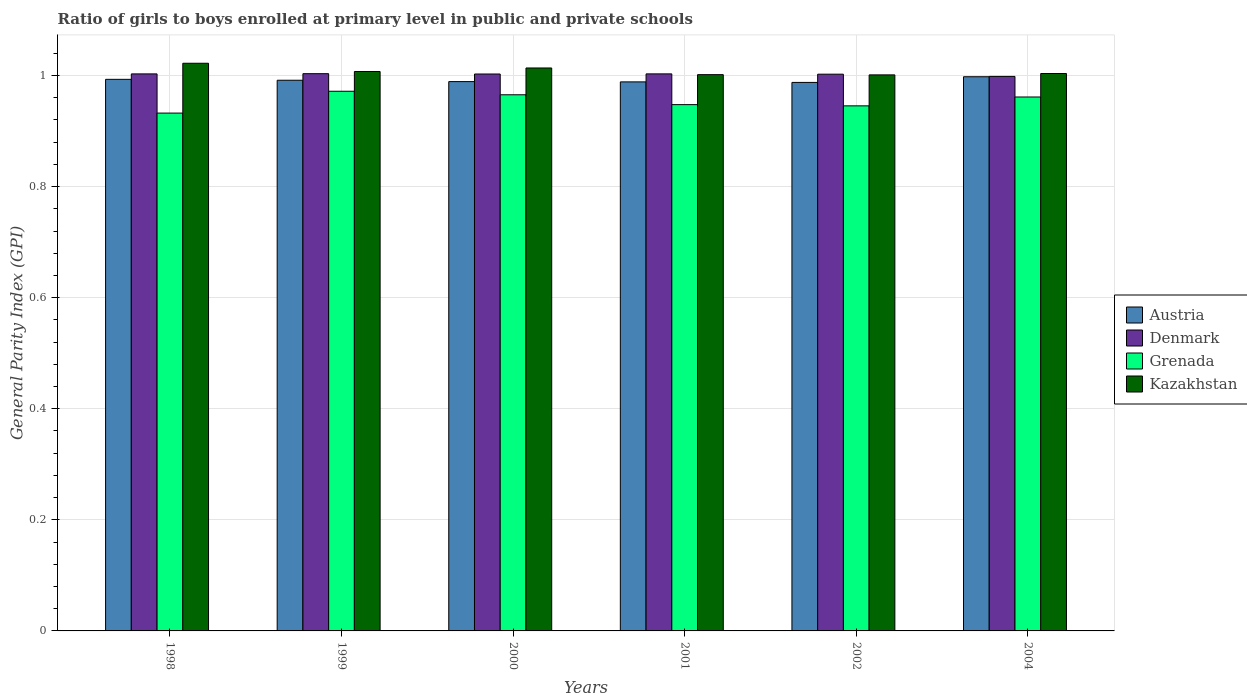How many groups of bars are there?
Ensure brevity in your answer.  6. How many bars are there on the 6th tick from the left?
Offer a very short reply. 4. What is the general parity index in Kazakhstan in 2001?
Keep it short and to the point. 1. Across all years, what is the maximum general parity index in Denmark?
Ensure brevity in your answer.  1. Across all years, what is the minimum general parity index in Grenada?
Give a very brief answer. 0.93. What is the total general parity index in Grenada in the graph?
Provide a succinct answer. 5.72. What is the difference between the general parity index in Grenada in 1998 and that in 2001?
Make the answer very short. -0.02. What is the difference between the general parity index in Grenada in 2000 and the general parity index in Kazakhstan in 1999?
Your answer should be very brief. -0.04. What is the average general parity index in Denmark per year?
Your response must be concise. 1. In the year 2000, what is the difference between the general parity index in Austria and general parity index in Grenada?
Keep it short and to the point. 0.02. What is the ratio of the general parity index in Denmark in 1999 to that in 2000?
Your answer should be very brief. 1. Is the general parity index in Denmark in 1998 less than that in 1999?
Offer a terse response. Yes. Is the difference between the general parity index in Austria in 1999 and 2002 greater than the difference between the general parity index in Grenada in 1999 and 2002?
Ensure brevity in your answer.  No. What is the difference between the highest and the second highest general parity index in Austria?
Ensure brevity in your answer.  0. What is the difference between the highest and the lowest general parity index in Kazakhstan?
Ensure brevity in your answer.  0.02. Is the sum of the general parity index in Grenada in 1999 and 2001 greater than the maximum general parity index in Kazakhstan across all years?
Your answer should be very brief. Yes. What does the 4th bar from the left in 1998 represents?
Make the answer very short. Kazakhstan. What does the 2nd bar from the right in 1998 represents?
Your answer should be compact. Grenada. Is it the case that in every year, the sum of the general parity index in Austria and general parity index in Grenada is greater than the general parity index in Kazakhstan?
Provide a short and direct response. Yes. Are the values on the major ticks of Y-axis written in scientific E-notation?
Keep it short and to the point. No. Does the graph contain grids?
Give a very brief answer. Yes. How many legend labels are there?
Keep it short and to the point. 4. How are the legend labels stacked?
Keep it short and to the point. Vertical. What is the title of the graph?
Provide a short and direct response. Ratio of girls to boys enrolled at primary level in public and private schools. Does "Sweden" appear as one of the legend labels in the graph?
Your answer should be very brief. No. What is the label or title of the X-axis?
Keep it short and to the point. Years. What is the label or title of the Y-axis?
Your answer should be compact. General Parity Index (GPI). What is the General Parity Index (GPI) of Austria in 1998?
Provide a succinct answer. 0.99. What is the General Parity Index (GPI) in Grenada in 1998?
Provide a short and direct response. 0.93. What is the General Parity Index (GPI) in Kazakhstan in 1998?
Your answer should be compact. 1.02. What is the General Parity Index (GPI) of Austria in 1999?
Offer a terse response. 0.99. What is the General Parity Index (GPI) in Denmark in 1999?
Make the answer very short. 1. What is the General Parity Index (GPI) in Grenada in 1999?
Give a very brief answer. 0.97. What is the General Parity Index (GPI) of Kazakhstan in 1999?
Provide a short and direct response. 1.01. What is the General Parity Index (GPI) in Austria in 2000?
Offer a terse response. 0.99. What is the General Parity Index (GPI) in Denmark in 2000?
Provide a succinct answer. 1. What is the General Parity Index (GPI) of Grenada in 2000?
Offer a very short reply. 0.97. What is the General Parity Index (GPI) of Kazakhstan in 2000?
Your answer should be very brief. 1.01. What is the General Parity Index (GPI) in Austria in 2001?
Ensure brevity in your answer.  0.99. What is the General Parity Index (GPI) of Denmark in 2001?
Make the answer very short. 1. What is the General Parity Index (GPI) of Grenada in 2001?
Ensure brevity in your answer.  0.95. What is the General Parity Index (GPI) in Kazakhstan in 2001?
Give a very brief answer. 1. What is the General Parity Index (GPI) in Austria in 2002?
Offer a very short reply. 0.99. What is the General Parity Index (GPI) in Denmark in 2002?
Your response must be concise. 1. What is the General Parity Index (GPI) of Grenada in 2002?
Keep it short and to the point. 0.95. What is the General Parity Index (GPI) in Kazakhstan in 2002?
Your response must be concise. 1. What is the General Parity Index (GPI) in Austria in 2004?
Offer a very short reply. 1. What is the General Parity Index (GPI) of Denmark in 2004?
Your response must be concise. 1. What is the General Parity Index (GPI) in Grenada in 2004?
Your response must be concise. 0.96. What is the General Parity Index (GPI) of Kazakhstan in 2004?
Offer a terse response. 1. Across all years, what is the maximum General Parity Index (GPI) of Austria?
Keep it short and to the point. 1. Across all years, what is the maximum General Parity Index (GPI) of Denmark?
Offer a terse response. 1. Across all years, what is the maximum General Parity Index (GPI) of Grenada?
Provide a short and direct response. 0.97. Across all years, what is the maximum General Parity Index (GPI) in Kazakhstan?
Keep it short and to the point. 1.02. Across all years, what is the minimum General Parity Index (GPI) of Austria?
Provide a succinct answer. 0.99. Across all years, what is the minimum General Parity Index (GPI) in Denmark?
Provide a succinct answer. 1. Across all years, what is the minimum General Parity Index (GPI) of Grenada?
Keep it short and to the point. 0.93. Across all years, what is the minimum General Parity Index (GPI) of Kazakhstan?
Your response must be concise. 1. What is the total General Parity Index (GPI) of Austria in the graph?
Ensure brevity in your answer.  5.95. What is the total General Parity Index (GPI) in Denmark in the graph?
Keep it short and to the point. 6.01. What is the total General Parity Index (GPI) in Grenada in the graph?
Your answer should be compact. 5.72. What is the total General Parity Index (GPI) in Kazakhstan in the graph?
Provide a succinct answer. 6.05. What is the difference between the General Parity Index (GPI) in Austria in 1998 and that in 1999?
Offer a terse response. 0. What is the difference between the General Parity Index (GPI) of Denmark in 1998 and that in 1999?
Offer a terse response. -0. What is the difference between the General Parity Index (GPI) of Grenada in 1998 and that in 1999?
Offer a terse response. -0.04. What is the difference between the General Parity Index (GPI) in Kazakhstan in 1998 and that in 1999?
Make the answer very short. 0.01. What is the difference between the General Parity Index (GPI) of Austria in 1998 and that in 2000?
Your answer should be compact. 0. What is the difference between the General Parity Index (GPI) in Denmark in 1998 and that in 2000?
Provide a short and direct response. 0. What is the difference between the General Parity Index (GPI) of Grenada in 1998 and that in 2000?
Offer a terse response. -0.03. What is the difference between the General Parity Index (GPI) of Kazakhstan in 1998 and that in 2000?
Offer a very short reply. 0.01. What is the difference between the General Parity Index (GPI) of Austria in 1998 and that in 2001?
Offer a terse response. 0. What is the difference between the General Parity Index (GPI) in Denmark in 1998 and that in 2001?
Your answer should be very brief. -0. What is the difference between the General Parity Index (GPI) in Grenada in 1998 and that in 2001?
Keep it short and to the point. -0.02. What is the difference between the General Parity Index (GPI) in Kazakhstan in 1998 and that in 2001?
Provide a short and direct response. 0.02. What is the difference between the General Parity Index (GPI) in Austria in 1998 and that in 2002?
Your response must be concise. 0.01. What is the difference between the General Parity Index (GPI) in Denmark in 1998 and that in 2002?
Your response must be concise. 0. What is the difference between the General Parity Index (GPI) of Grenada in 1998 and that in 2002?
Your answer should be compact. -0.01. What is the difference between the General Parity Index (GPI) in Kazakhstan in 1998 and that in 2002?
Give a very brief answer. 0.02. What is the difference between the General Parity Index (GPI) in Austria in 1998 and that in 2004?
Provide a short and direct response. -0. What is the difference between the General Parity Index (GPI) in Denmark in 1998 and that in 2004?
Your answer should be very brief. 0. What is the difference between the General Parity Index (GPI) in Grenada in 1998 and that in 2004?
Offer a very short reply. -0.03. What is the difference between the General Parity Index (GPI) in Kazakhstan in 1998 and that in 2004?
Make the answer very short. 0.02. What is the difference between the General Parity Index (GPI) in Austria in 1999 and that in 2000?
Keep it short and to the point. 0. What is the difference between the General Parity Index (GPI) in Denmark in 1999 and that in 2000?
Ensure brevity in your answer.  0. What is the difference between the General Parity Index (GPI) in Grenada in 1999 and that in 2000?
Give a very brief answer. 0.01. What is the difference between the General Parity Index (GPI) of Kazakhstan in 1999 and that in 2000?
Ensure brevity in your answer.  -0.01. What is the difference between the General Parity Index (GPI) of Austria in 1999 and that in 2001?
Ensure brevity in your answer.  0. What is the difference between the General Parity Index (GPI) of Denmark in 1999 and that in 2001?
Make the answer very short. 0. What is the difference between the General Parity Index (GPI) in Grenada in 1999 and that in 2001?
Provide a succinct answer. 0.02. What is the difference between the General Parity Index (GPI) of Kazakhstan in 1999 and that in 2001?
Make the answer very short. 0.01. What is the difference between the General Parity Index (GPI) in Austria in 1999 and that in 2002?
Provide a succinct answer. 0. What is the difference between the General Parity Index (GPI) in Denmark in 1999 and that in 2002?
Keep it short and to the point. 0. What is the difference between the General Parity Index (GPI) of Grenada in 1999 and that in 2002?
Your answer should be compact. 0.03. What is the difference between the General Parity Index (GPI) of Kazakhstan in 1999 and that in 2002?
Ensure brevity in your answer.  0.01. What is the difference between the General Parity Index (GPI) of Austria in 1999 and that in 2004?
Ensure brevity in your answer.  -0.01. What is the difference between the General Parity Index (GPI) of Denmark in 1999 and that in 2004?
Offer a terse response. 0. What is the difference between the General Parity Index (GPI) in Grenada in 1999 and that in 2004?
Give a very brief answer. 0.01. What is the difference between the General Parity Index (GPI) of Kazakhstan in 1999 and that in 2004?
Your response must be concise. 0. What is the difference between the General Parity Index (GPI) of Austria in 2000 and that in 2001?
Your answer should be very brief. 0. What is the difference between the General Parity Index (GPI) of Denmark in 2000 and that in 2001?
Offer a very short reply. -0. What is the difference between the General Parity Index (GPI) of Grenada in 2000 and that in 2001?
Offer a very short reply. 0.02. What is the difference between the General Parity Index (GPI) of Kazakhstan in 2000 and that in 2001?
Your answer should be very brief. 0.01. What is the difference between the General Parity Index (GPI) in Austria in 2000 and that in 2002?
Your answer should be compact. 0. What is the difference between the General Parity Index (GPI) in Grenada in 2000 and that in 2002?
Offer a terse response. 0.02. What is the difference between the General Parity Index (GPI) of Kazakhstan in 2000 and that in 2002?
Offer a terse response. 0.01. What is the difference between the General Parity Index (GPI) in Austria in 2000 and that in 2004?
Offer a terse response. -0.01. What is the difference between the General Parity Index (GPI) of Denmark in 2000 and that in 2004?
Give a very brief answer. 0. What is the difference between the General Parity Index (GPI) of Grenada in 2000 and that in 2004?
Provide a short and direct response. 0. What is the difference between the General Parity Index (GPI) in Kazakhstan in 2000 and that in 2004?
Keep it short and to the point. 0.01. What is the difference between the General Parity Index (GPI) of Austria in 2001 and that in 2002?
Your answer should be compact. 0. What is the difference between the General Parity Index (GPI) of Denmark in 2001 and that in 2002?
Give a very brief answer. 0. What is the difference between the General Parity Index (GPI) of Grenada in 2001 and that in 2002?
Your response must be concise. 0. What is the difference between the General Parity Index (GPI) in Austria in 2001 and that in 2004?
Your answer should be very brief. -0.01. What is the difference between the General Parity Index (GPI) of Denmark in 2001 and that in 2004?
Provide a short and direct response. 0. What is the difference between the General Parity Index (GPI) in Grenada in 2001 and that in 2004?
Offer a very short reply. -0.01. What is the difference between the General Parity Index (GPI) of Kazakhstan in 2001 and that in 2004?
Ensure brevity in your answer.  -0. What is the difference between the General Parity Index (GPI) in Austria in 2002 and that in 2004?
Make the answer very short. -0.01. What is the difference between the General Parity Index (GPI) of Denmark in 2002 and that in 2004?
Your answer should be compact. 0. What is the difference between the General Parity Index (GPI) in Grenada in 2002 and that in 2004?
Give a very brief answer. -0.02. What is the difference between the General Parity Index (GPI) in Kazakhstan in 2002 and that in 2004?
Make the answer very short. -0. What is the difference between the General Parity Index (GPI) of Austria in 1998 and the General Parity Index (GPI) of Denmark in 1999?
Your response must be concise. -0.01. What is the difference between the General Parity Index (GPI) in Austria in 1998 and the General Parity Index (GPI) in Grenada in 1999?
Provide a succinct answer. 0.02. What is the difference between the General Parity Index (GPI) in Austria in 1998 and the General Parity Index (GPI) in Kazakhstan in 1999?
Your answer should be compact. -0.01. What is the difference between the General Parity Index (GPI) in Denmark in 1998 and the General Parity Index (GPI) in Grenada in 1999?
Provide a short and direct response. 0.03. What is the difference between the General Parity Index (GPI) in Denmark in 1998 and the General Parity Index (GPI) in Kazakhstan in 1999?
Your answer should be compact. -0. What is the difference between the General Parity Index (GPI) of Grenada in 1998 and the General Parity Index (GPI) of Kazakhstan in 1999?
Ensure brevity in your answer.  -0.07. What is the difference between the General Parity Index (GPI) in Austria in 1998 and the General Parity Index (GPI) in Denmark in 2000?
Your answer should be very brief. -0.01. What is the difference between the General Parity Index (GPI) of Austria in 1998 and the General Parity Index (GPI) of Grenada in 2000?
Give a very brief answer. 0.03. What is the difference between the General Parity Index (GPI) in Austria in 1998 and the General Parity Index (GPI) in Kazakhstan in 2000?
Your answer should be compact. -0.02. What is the difference between the General Parity Index (GPI) of Denmark in 1998 and the General Parity Index (GPI) of Grenada in 2000?
Provide a short and direct response. 0.04. What is the difference between the General Parity Index (GPI) in Denmark in 1998 and the General Parity Index (GPI) in Kazakhstan in 2000?
Your answer should be very brief. -0.01. What is the difference between the General Parity Index (GPI) in Grenada in 1998 and the General Parity Index (GPI) in Kazakhstan in 2000?
Your answer should be compact. -0.08. What is the difference between the General Parity Index (GPI) in Austria in 1998 and the General Parity Index (GPI) in Denmark in 2001?
Offer a terse response. -0.01. What is the difference between the General Parity Index (GPI) of Austria in 1998 and the General Parity Index (GPI) of Grenada in 2001?
Your answer should be very brief. 0.05. What is the difference between the General Parity Index (GPI) of Austria in 1998 and the General Parity Index (GPI) of Kazakhstan in 2001?
Provide a short and direct response. -0.01. What is the difference between the General Parity Index (GPI) in Denmark in 1998 and the General Parity Index (GPI) in Grenada in 2001?
Provide a succinct answer. 0.06. What is the difference between the General Parity Index (GPI) in Denmark in 1998 and the General Parity Index (GPI) in Kazakhstan in 2001?
Make the answer very short. 0. What is the difference between the General Parity Index (GPI) of Grenada in 1998 and the General Parity Index (GPI) of Kazakhstan in 2001?
Provide a short and direct response. -0.07. What is the difference between the General Parity Index (GPI) of Austria in 1998 and the General Parity Index (GPI) of Denmark in 2002?
Offer a very short reply. -0.01. What is the difference between the General Parity Index (GPI) in Austria in 1998 and the General Parity Index (GPI) in Grenada in 2002?
Ensure brevity in your answer.  0.05. What is the difference between the General Parity Index (GPI) of Austria in 1998 and the General Parity Index (GPI) of Kazakhstan in 2002?
Your answer should be very brief. -0.01. What is the difference between the General Parity Index (GPI) of Denmark in 1998 and the General Parity Index (GPI) of Grenada in 2002?
Ensure brevity in your answer.  0.06. What is the difference between the General Parity Index (GPI) in Denmark in 1998 and the General Parity Index (GPI) in Kazakhstan in 2002?
Provide a succinct answer. 0. What is the difference between the General Parity Index (GPI) of Grenada in 1998 and the General Parity Index (GPI) of Kazakhstan in 2002?
Make the answer very short. -0.07. What is the difference between the General Parity Index (GPI) of Austria in 1998 and the General Parity Index (GPI) of Denmark in 2004?
Ensure brevity in your answer.  -0.01. What is the difference between the General Parity Index (GPI) of Austria in 1998 and the General Parity Index (GPI) of Grenada in 2004?
Give a very brief answer. 0.03. What is the difference between the General Parity Index (GPI) in Austria in 1998 and the General Parity Index (GPI) in Kazakhstan in 2004?
Offer a very short reply. -0.01. What is the difference between the General Parity Index (GPI) in Denmark in 1998 and the General Parity Index (GPI) in Grenada in 2004?
Make the answer very short. 0.04. What is the difference between the General Parity Index (GPI) in Denmark in 1998 and the General Parity Index (GPI) in Kazakhstan in 2004?
Offer a very short reply. -0. What is the difference between the General Parity Index (GPI) of Grenada in 1998 and the General Parity Index (GPI) of Kazakhstan in 2004?
Keep it short and to the point. -0.07. What is the difference between the General Parity Index (GPI) in Austria in 1999 and the General Parity Index (GPI) in Denmark in 2000?
Make the answer very short. -0.01. What is the difference between the General Parity Index (GPI) of Austria in 1999 and the General Parity Index (GPI) of Grenada in 2000?
Provide a short and direct response. 0.03. What is the difference between the General Parity Index (GPI) of Austria in 1999 and the General Parity Index (GPI) of Kazakhstan in 2000?
Offer a very short reply. -0.02. What is the difference between the General Parity Index (GPI) of Denmark in 1999 and the General Parity Index (GPI) of Grenada in 2000?
Ensure brevity in your answer.  0.04. What is the difference between the General Parity Index (GPI) of Denmark in 1999 and the General Parity Index (GPI) of Kazakhstan in 2000?
Offer a terse response. -0.01. What is the difference between the General Parity Index (GPI) of Grenada in 1999 and the General Parity Index (GPI) of Kazakhstan in 2000?
Provide a succinct answer. -0.04. What is the difference between the General Parity Index (GPI) in Austria in 1999 and the General Parity Index (GPI) in Denmark in 2001?
Provide a succinct answer. -0.01. What is the difference between the General Parity Index (GPI) of Austria in 1999 and the General Parity Index (GPI) of Grenada in 2001?
Give a very brief answer. 0.04. What is the difference between the General Parity Index (GPI) in Austria in 1999 and the General Parity Index (GPI) in Kazakhstan in 2001?
Keep it short and to the point. -0.01. What is the difference between the General Parity Index (GPI) in Denmark in 1999 and the General Parity Index (GPI) in Grenada in 2001?
Your response must be concise. 0.06. What is the difference between the General Parity Index (GPI) in Denmark in 1999 and the General Parity Index (GPI) in Kazakhstan in 2001?
Offer a terse response. 0. What is the difference between the General Parity Index (GPI) of Grenada in 1999 and the General Parity Index (GPI) of Kazakhstan in 2001?
Ensure brevity in your answer.  -0.03. What is the difference between the General Parity Index (GPI) of Austria in 1999 and the General Parity Index (GPI) of Denmark in 2002?
Provide a succinct answer. -0.01. What is the difference between the General Parity Index (GPI) in Austria in 1999 and the General Parity Index (GPI) in Grenada in 2002?
Your answer should be very brief. 0.05. What is the difference between the General Parity Index (GPI) of Austria in 1999 and the General Parity Index (GPI) of Kazakhstan in 2002?
Make the answer very short. -0.01. What is the difference between the General Parity Index (GPI) in Denmark in 1999 and the General Parity Index (GPI) in Grenada in 2002?
Your response must be concise. 0.06. What is the difference between the General Parity Index (GPI) in Denmark in 1999 and the General Parity Index (GPI) in Kazakhstan in 2002?
Make the answer very short. 0. What is the difference between the General Parity Index (GPI) in Grenada in 1999 and the General Parity Index (GPI) in Kazakhstan in 2002?
Keep it short and to the point. -0.03. What is the difference between the General Parity Index (GPI) of Austria in 1999 and the General Parity Index (GPI) of Denmark in 2004?
Make the answer very short. -0.01. What is the difference between the General Parity Index (GPI) of Austria in 1999 and the General Parity Index (GPI) of Grenada in 2004?
Your answer should be compact. 0.03. What is the difference between the General Parity Index (GPI) of Austria in 1999 and the General Parity Index (GPI) of Kazakhstan in 2004?
Provide a short and direct response. -0.01. What is the difference between the General Parity Index (GPI) of Denmark in 1999 and the General Parity Index (GPI) of Grenada in 2004?
Provide a succinct answer. 0.04. What is the difference between the General Parity Index (GPI) in Denmark in 1999 and the General Parity Index (GPI) in Kazakhstan in 2004?
Offer a terse response. -0. What is the difference between the General Parity Index (GPI) of Grenada in 1999 and the General Parity Index (GPI) of Kazakhstan in 2004?
Offer a terse response. -0.03. What is the difference between the General Parity Index (GPI) of Austria in 2000 and the General Parity Index (GPI) of Denmark in 2001?
Keep it short and to the point. -0.01. What is the difference between the General Parity Index (GPI) in Austria in 2000 and the General Parity Index (GPI) in Grenada in 2001?
Offer a terse response. 0.04. What is the difference between the General Parity Index (GPI) of Austria in 2000 and the General Parity Index (GPI) of Kazakhstan in 2001?
Make the answer very short. -0.01. What is the difference between the General Parity Index (GPI) of Denmark in 2000 and the General Parity Index (GPI) of Grenada in 2001?
Offer a terse response. 0.06. What is the difference between the General Parity Index (GPI) in Denmark in 2000 and the General Parity Index (GPI) in Kazakhstan in 2001?
Your answer should be compact. 0. What is the difference between the General Parity Index (GPI) in Grenada in 2000 and the General Parity Index (GPI) in Kazakhstan in 2001?
Your response must be concise. -0.04. What is the difference between the General Parity Index (GPI) of Austria in 2000 and the General Parity Index (GPI) of Denmark in 2002?
Your response must be concise. -0.01. What is the difference between the General Parity Index (GPI) in Austria in 2000 and the General Parity Index (GPI) in Grenada in 2002?
Your answer should be very brief. 0.04. What is the difference between the General Parity Index (GPI) in Austria in 2000 and the General Parity Index (GPI) in Kazakhstan in 2002?
Your answer should be very brief. -0.01. What is the difference between the General Parity Index (GPI) in Denmark in 2000 and the General Parity Index (GPI) in Grenada in 2002?
Ensure brevity in your answer.  0.06. What is the difference between the General Parity Index (GPI) of Denmark in 2000 and the General Parity Index (GPI) of Kazakhstan in 2002?
Provide a succinct answer. 0. What is the difference between the General Parity Index (GPI) of Grenada in 2000 and the General Parity Index (GPI) of Kazakhstan in 2002?
Provide a short and direct response. -0.04. What is the difference between the General Parity Index (GPI) in Austria in 2000 and the General Parity Index (GPI) in Denmark in 2004?
Provide a short and direct response. -0.01. What is the difference between the General Parity Index (GPI) in Austria in 2000 and the General Parity Index (GPI) in Grenada in 2004?
Provide a short and direct response. 0.03. What is the difference between the General Parity Index (GPI) in Austria in 2000 and the General Parity Index (GPI) in Kazakhstan in 2004?
Your answer should be compact. -0.01. What is the difference between the General Parity Index (GPI) of Denmark in 2000 and the General Parity Index (GPI) of Grenada in 2004?
Offer a very short reply. 0.04. What is the difference between the General Parity Index (GPI) in Denmark in 2000 and the General Parity Index (GPI) in Kazakhstan in 2004?
Keep it short and to the point. -0. What is the difference between the General Parity Index (GPI) of Grenada in 2000 and the General Parity Index (GPI) of Kazakhstan in 2004?
Your answer should be compact. -0.04. What is the difference between the General Parity Index (GPI) of Austria in 2001 and the General Parity Index (GPI) of Denmark in 2002?
Ensure brevity in your answer.  -0.01. What is the difference between the General Parity Index (GPI) of Austria in 2001 and the General Parity Index (GPI) of Grenada in 2002?
Make the answer very short. 0.04. What is the difference between the General Parity Index (GPI) of Austria in 2001 and the General Parity Index (GPI) of Kazakhstan in 2002?
Give a very brief answer. -0.01. What is the difference between the General Parity Index (GPI) in Denmark in 2001 and the General Parity Index (GPI) in Grenada in 2002?
Give a very brief answer. 0.06. What is the difference between the General Parity Index (GPI) of Denmark in 2001 and the General Parity Index (GPI) of Kazakhstan in 2002?
Your answer should be compact. 0. What is the difference between the General Parity Index (GPI) of Grenada in 2001 and the General Parity Index (GPI) of Kazakhstan in 2002?
Your response must be concise. -0.05. What is the difference between the General Parity Index (GPI) in Austria in 2001 and the General Parity Index (GPI) in Denmark in 2004?
Ensure brevity in your answer.  -0.01. What is the difference between the General Parity Index (GPI) of Austria in 2001 and the General Parity Index (GPI) of Grenada in 2004?
Keep it short and to the point. 0.03. What is the difference between the General Parity Index (GPI) of Austria in 2001 and the General Parity Index (GPI) of Kazakhstan in 2004?
Make the answer very short. -0.02. What is the difference between the General Parity Index (GPI) of Denmark in 2001 and the General Parity Index (GPI) of Grenada in 2004?
Offer a very short reply. 0.04. What is the difference between the General Parity Index (GPI) in Denmark in 2001 and the General Parity Index (GPI) in Kazakhstan in 2004?
Keep it short and to the point. -0. What is the difference between the General Parity Index (GPI) of Grenada in 2001 and the General Parity Index (GPI) of Kazakhstan in 2004?
Provide a short and direct response. -0.06. What is the difference between the General Parity Index (GPI) in Austria in 2002 and the General Parity Index (GPI) in Denmark in 2004?
Your answer should be very brief. -0.01. What is the difference between the General Parity Index (GPI) of Austria in 2002 and the General Parity Index (GPI) of Grenada in 2004?
Provide a short and direct response. 0.03. What is the difference between the General Parity Index (GPI) of Austria in 2002 and the General Parity Index (GPI) of Kazakhstan in 2004?
Offer a very short reply. -0.02. What is the difference between the General Parity Index (GPI) of Denmark in 2002 and the General Parity Index (GPI) of Grenada in 2004?
Give a very brief answer. 0.04. What is the difference between the General Parity Index (GPI) in Denmark in 2002 and the General Parity Index (GPI) in Kazakhstan in 2004?
Your response must be concise. -0. What is the difference between the General Parity Index (GPI) of Grenada in 2002 and the General Parity Index (GPI) of Kazakhstan in 2004?
Offer a terse response. -0.06. What is the average General Parity Index (GPI) of Austria per year?
Give a very brief answer. 0.99. What is the average General Parity Index (GPI) of Grenada per year?
Your response must be concise. 0.95. What is the average General Parity Index (GPI) in Kazakhstan per year?
Your answer should be very brief. 1.01. In the year 1998, what is the difference between the General Parity Index (GPI) in Austria and General Parity Index (GPI) in Denmark?
Ensure brevity in your answer.  -0.01. In the year 1998, what is the difference between the General Parity Index (GPI) in Austria and General Parity Index (GPI) in Grenada?
Your response must be concise. 0.06. In the year 1998, what is the difference between the General Parity Index (GPI) of Austria and General Parity Index (GPI) of Kazakhstan?
Keep it short and to the point. -0.03. In the year 1998, what is the difference between the General Parity Index (GPI) of Denmark and General Parity Index (GPI) of Grenada?
Make the answer very short. 0.07. In the year 1998, what is the difference between the General Parity Index (GPI) of Denmark and General Parity Index (GPI) of Kazakhstan?
Keep it short and to the point. -0.02. In the year 1998, what is the difference between the General Parity Index (GPI) in Grenada and General Parity Index (GPI) in Kazakhstan?
Provide a succinct answer. -0.09. In the year 1999, what is the difference between the General Parity Index (GPI) in Austria and General Parity Index (GPI) in Denmark?
Your answer should be very brief. -0.01. In the year 1999, what is the difference between the General Parity Index (GPI) in Austria and General Parity Index (GPI) in Grenada?
Your answer should be compact. 0.02. In the year 1999, what is the difference between the General Parity Index (GPI) of Austria and General Parity Index (GPI) of Kazakhstan?
Your response must be concise. -0.02. In the year 1999, what is the difference between the General Parity Index (GPI) of Denmark and General Parity Index (GPI) of Grenada?
Your answer should be compact. 0.03. In the year 1999, what is the difference between the General Parity Index (GPI) in Denmark and General Parity Index (GPI) in Kazakhstan?
Offer a terse response. -0. In the year 1999, what is the difference between the General Parity Index (GPI) of Grenada and General Parity Index (GPI) of Kazakhstan?
Your answer should be very brief. -0.04. In the year 2000, what is the difference between the General Parity Index (GPI) of Austria and General Parity Index (GPI) of Denmark?
Offer a very short reply. -0.01. In the year 2000, what is the difference between the General Parity Index (GPI) of Austria and General Parity Index (GPI) of Grenada?
Make the answer very short. 0.02. In the year 2000, what is the difference between the General Parity Index (GPI) in Austria and General Parity Index (GPI) in Kazakhstan?
Your answer should be compact. -0.02. In the year 2000, what is the difference between the General Parity Index (GPI) of Denmark and General Parity Index (GPI) of Grenada?
Offer a very short reply. 0.04. In the year 2000, what is the difference between the General Parity Index (GPI) in Denmark and General Parity Index (GPI) in Kazakhstan?
Keep it short and to the point. -0.01. In the year 2000, what is the difference between the General Parity Index (GPI) of Grenada and General Parity Index (GPI) of Kazakhstan?
Give a very brief answer. -0.05. In the year 2001, what is the difference between the General Parity Index (GPI) in Austria and General Parity Index (GPI) in Denmark?
Give a very brief answer. -0.01. In the year 2001, what is the difference between the General Parity Index (GPI) in Austria and General Parity Index (GPI) in Grenada?
Your answer should be compact. 0.04. In the year 2001, what is the difference between the General Parity Index (GPI) in Austria and General Parity Index (GPI) in Kazakhstan?
Your answer should be very brief. -0.01. In the year 2001, what is the difference between the General Parity Index (GPI) in Denmark and General Parity Index (GPI) in Grenada?
Your answer should be very brief. 0.06. In the year 2001, what is the difference between the General Parity Index (GPI) of Denmark and General Parity Index (GPI) of Kazakhstan?
Offer a terse response. 0. In the year 2001, what is the difference between the General Parity Index (GPI) in Grenada and General Parity Index (GPI) in Kazakhstan?
Your response must be concise. -0.05. In the year 2002, what is the difference between the General Parity Index (GPI) in Austria and General Parity Index (GPI) in Denmark?
Offer a terse response. -0.01. In the year 2002, what is the difference between the General Parity Index (GPI) in Austria and General Parity Index (GPI) in Grenada?
Offer a very short reply. 0.04. In the year 2002, what is the difference between the General Parity Index (GPI) of Austria and General Parity Index (GPI) of Kazakhstan?
Ensure brevity in your answer.  -0.01. In the year 2002, what is the difference between the General Parity Index (GPI) of Denmark and General Parity Index (GPI) of Grenada?
Offer a terse response. 0.06. In the year 2002, what is the difference between the General Parity Index (GPI) of Denmark and General Parity Index (GPI) of Kazakhstan?
Your answer should be very brief. 0. In the year 2002, what is the difference between the General Parity Index (GPI) of Grenada and General Parity Index (GPI) of Kazakhstan?
Your answer should be compact. -0.06. In the year 2004, what is the difference between the General Parity Index (GPI) of Austria and General Parity Index (GPI) of Denmark?
Offer a very short reply. -0. In the year 2004, what is the difference between the General Parity Index (GPI) of Austria and General Parity Index (GPI) of Grenada?
Your response must be concise. 0.04. In the year 2004, what is the difference between the General Parity Index (GPI) of Austria and General Parity Index (GPI) of Kazakhstan?
Keep it short and to the point. -0.01. In the year 2004, what is the difference between the General Parity Index (GPI) in Denmark and General Parity Index (GPI) in Grenada?
Ensure brevity in your answer.  0.04. In the year 2004, what is the difference between the General Parity Index (GPI) of Denmark and General Parity Index (GPI) of Kazakhstan?
Keep it short and to the point. -0.01. In the year 2004, what is the difference between the General Parity Index (GPI) in Grenada and General Parity Index (GPI) in Kazakhstan?
Your response must be concise. -0.04. What is the ratio of the General Parity Index (GPI) in Austria in 1998 to that in 1999?
Your response must be concise. 1. What is the ratio of the General Parity Index (GPI) of Grenada in 1998 to that in 1999?
Keep it short and to the point. 0.96. What is the ratio of the General Parity Index (GPI) of Kazakhstan in 1998 to that in 1999?
Ensure brevity in your answer.  1.01. What is the ratio of the General Parity Index (GPI) of Austria in 1998 to that in 2000?
Keep it short and to the point. 1. What is the ratio of the General Parity Index (GPI) of Grenada in 1998 to that in 2000?
Your response must be concise. 0.97. What is the ratio of the General Parity Index (GPI) of Kazakhstan in 1998 to that in 2000?
Your answer should be compact. 1.01. What is the ratio of the General Parity Index (GPI) in Austria in 1998 to that in 2001?
Make the answer very short. 1. What is the ratio of the General Parity Index (GPI) of Denmark in 1998 to that in 2001?
Make the answer very short. 1. What is the ratio of the General Parity Index (GPI) in Grenada in 1998 to that in 2001?
Ensure brevity in your answer.  0.98. What is the ratio of the General Parity Index (GPI) of Kazakhstan in 1998 to that in 2001?
Give a very brief answer. 1.02. What is the ratio of the General Parity Index (GPI) in Austria in 1998 to that in 2002?
Your answer should be compact. 1.01. What is the ratio of the General Parity Index (GPI) in Denmark in 1998 to that in 2002?
Offer a very short reply. 1. What is the ratio of the General Parity Index (GPI) of Grenada in 1998 to that in 2002?
Ensure brevity in your answer.  0.99. What is the ratio of the General Parity Index (GPI) of Kazakhstan in 1998 to that in 2002?
Your response must be concise. 1.02. What is the ratio of the General Parity Index (GPI) in Denmark in 1998 to that in 2004?
Keep it short and to the point. 1. What is the ratio of the General Parity Index (GPI) of Grenada in 1998 to that in 2004?
Give a very brief answer. 0.97. What is the ratio of the General Parity Index (GPI) in Kazakhstan in 1998 to that in 2004?
Offer a very short reply. 1.02. What is the ratio of the General Parity Index (GPI) of Grenada in 1999 to that in 2000?
Your response must be concise. 1.01. What is the ratio of the General Parity Index (GPI) in Grenada in 1999 to that in 2001?
Your answer should be compact. 1.03. What is the ratio of the General Parity Index (GPI) of Austria in 1999 to that in 2002?
Offer a terse response. 1. What is the ratio of the General Parity Index (GPI) in Denmark in 1999 to that in 2002?
Offer a terse response. 1. What is the ratio of the General Parity Index (GPI) of Grenada in 1999 to that in 2002?
Offer a very short reply. 1.03. What is the ratio of the General Parity Index (GPI) of Kazakhstan in 1999 to that in 2002?
Offer a terse response. 1.01. What is the ratio of the General Parity Index (GPI) of Denmark in 1999 to that in 2004?
Offer a very short reply. 1. What is the ratio of the General Parity Index (GPI) in Grenada in 1999 to that in 2004?
Offer a terse response. 1.01. What is the ratio of the General Parity Index (GPI) of Denmark in 2000 to that in 2001?
Keep it short and to the point. 1. What is the ratio of the General Parity Index (GPI) of Grenada in 2000 to that in 2001?
Offer a very short reply. 1.02. What is the ratio of the General Parity Index (GPI) in Kazakhstan in 2000 to that in 2001?
Keep it short and to the point. 1.01. What is the ratio of the General Parity Index (GPI) in Grenada in 2000 to that in 2002?
Your response must be concise. 1.02. What is the ratio of the General Parity Index (GPI) of Kazakhstan in 2000 to that in 2002?
Your response must be concise. 1.01. What is the ratio of the General Parity Index (GPI) in Kazakhstan in 2000 to that in 2004?
Offer a very short reply. 1.01. What is the ratio of the General Parity Index (GPI) of Denmark in 2001 to that in 2002?
Your answer should be very brief. 1. What is the ratio of the General Parity Index (GPI) in Grenada in 2001 to that in 2002?
Provide a succinct answer. 1. What is the ratio of the General Parity Index (GPI) in Kazakhstan in 2001 to that in 2002?
Make the answer very short. 1. What is the ratio of the General Parity Index (GPI) in Denmark in 2001 to that in 2004?
Provide a succinct answer. 1. What is the ratio of the General Parity Index (GPI) in Grenada in 2001 to that in 2004?
Provide a succinct answer. 0.99. What is the ratio of the General Parity Index (GPI) of Austria in 2002 to that in 2004?
Give a very brief answer. 0.99. What is the ratio of the General Parity Index (GPI) in Denmark in 2002 to that in 2004?
Ensure brevity in your answer.  1. What is the ratio of the General Parity Index (GPI) of Grenada in 2002 to that in 2004?
Your response must be concise. 0.98. What is the difference between the highest and the second highest General Parity Index (GPI) in Austria?
Give a very brief answer. 0. What is the difference between the highest and the second highest General Parity Index (GPI) in Denmark?
Make the answer very short. 0. What is the difference between the highest and the second highest General Parity Index (GPI) in Grenada?
Your answer should be very brief. 0.01. What is the difference between the highest and the second highest General Parity Index (GPI) of Kazakhstan?
Offer a terse response. 0.01. What is the difference between the highest and the lowest General Parity Index (GPI) of Austria?
Your answer should be very brief. 0.01. What is the difference between the highest and the lowest General Parity Index (GPI) in Denmark?
Provide a succinct answer. 0. What is the difference between the highest and the lowest General Parity Index (GPI) of Grenada?
Ensure brevity in your answer.  0.04. What is the difference between the highest and the lowest General Parity Index (GPI) in Kazakhstan?
Keep it short and to the point. 0.02. 